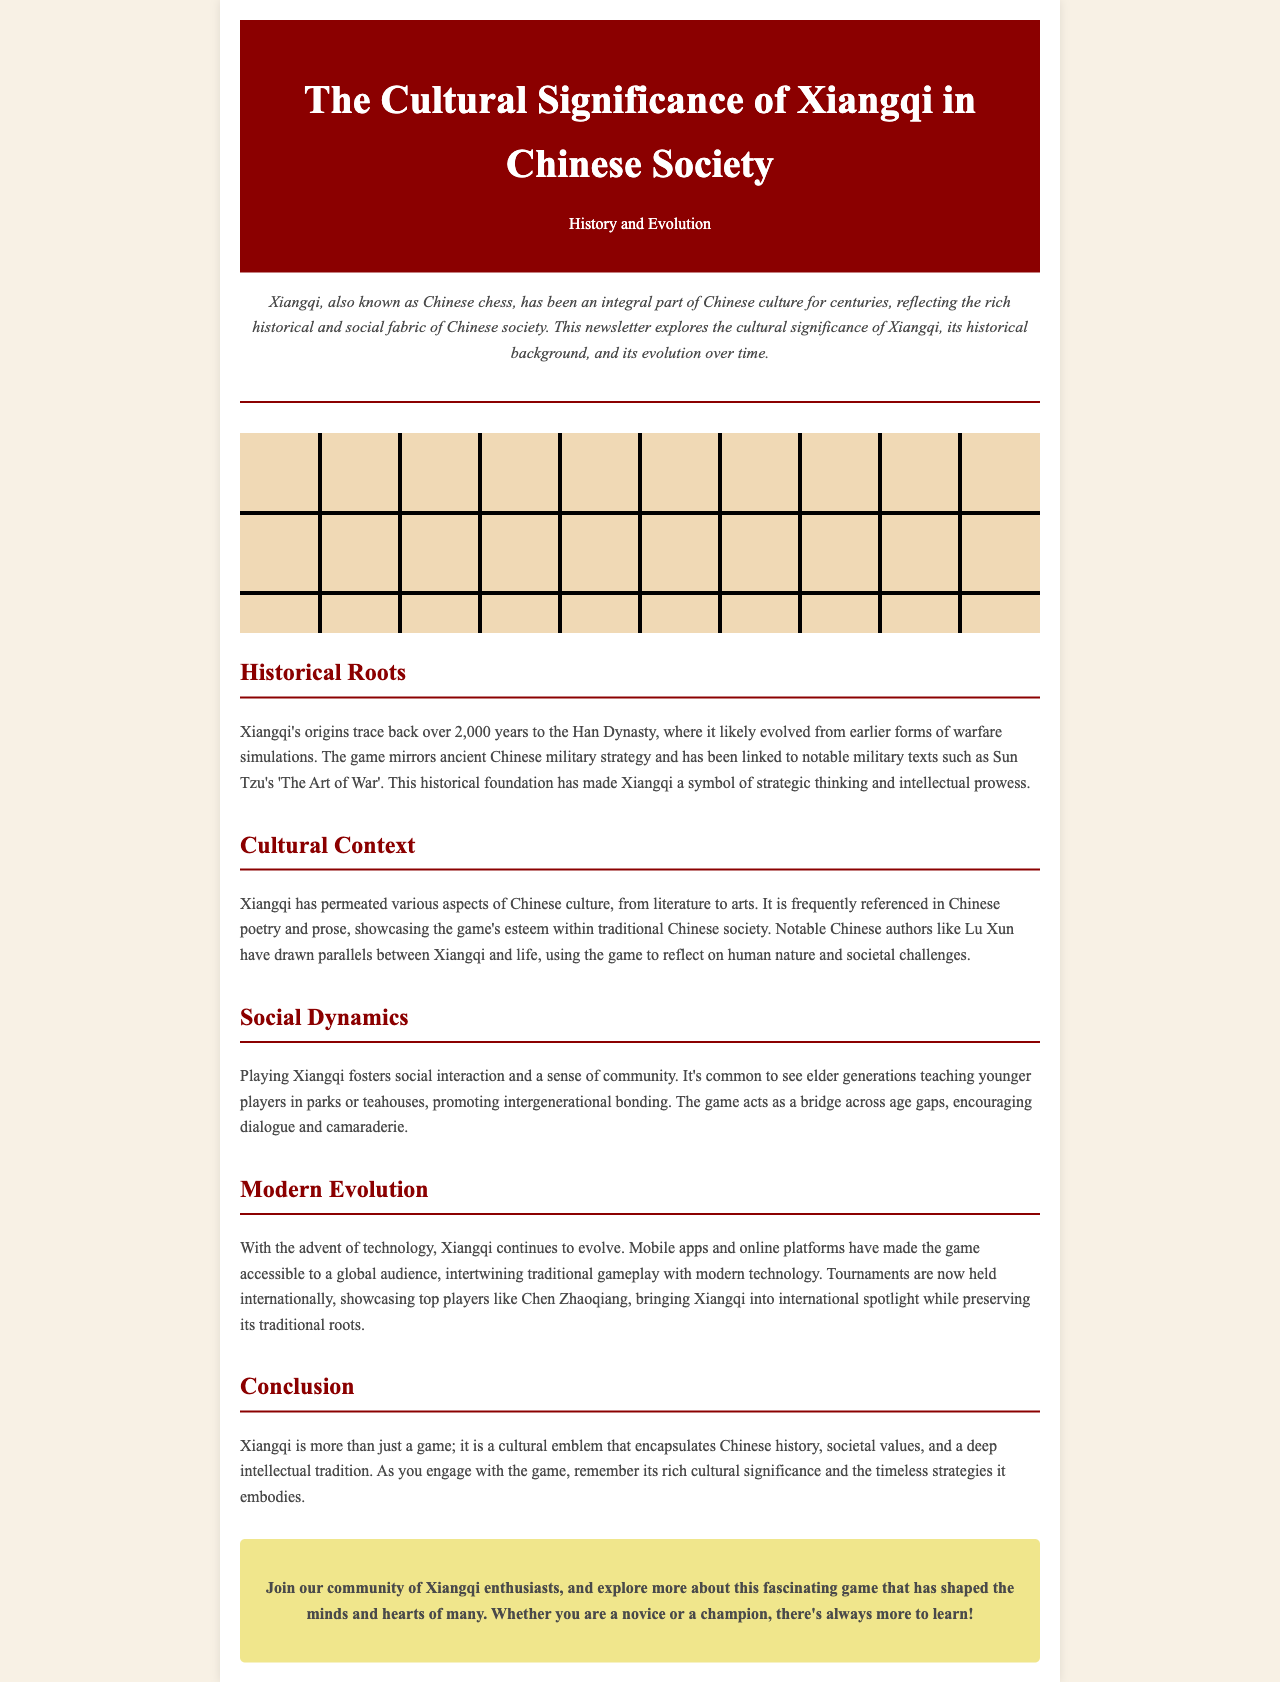what is the historical origin of Xiangqi? The document states that Xiangqi's origins trace back over 2,000 years to the Han Dynasty.
Answer: Han Dynasty who is a notable player mentioned in the modern evolution section? The document mentions Chen Zhaoqiang as a notable player in international tournaments.
Answer: Chen Zhaoqiang how does playing Xiangqi promote social interaction? The document explains that it is common to see elder generations teaching younger players, promoting intergenerational bonding.
Answer: Intergenerational bonding what is a cultural context where Xiangqi is referenced? The document states that Xiangqi is frequently referenced in Chinese poetry and prose.
Answer: Chinese poetry and prose how many years ago did Xiangqi originate? The document states that Xiangqi's origins trace back over 2,000 years.
Answer: 2000 years what does Xiangqi symbolize in Chinese society? The document describes Xiangqi as a symbol of strategic thinking and intellectual prowess.
Answer: Strategic thinking and intellectual prowess which military text is linked to Xiangqi? The document mentions Sun Tzu's 'The Art of War' as a notable military text linked to Xiangqi.
Answer: 'The Art of War' what does the introduction of the newsletter describe? The introduction explains that Xiangqi has been an integral part of Chinese culture for centuries, reflecting historical and social fabric.
Answer: Integral part of Chinese culture what is the purpose of the call-to-action section? The document calls readers to join the community of Xiangqi enthusiasts to explore more about the game.
Answer: Join the community of Xiangqi enthusiasts 